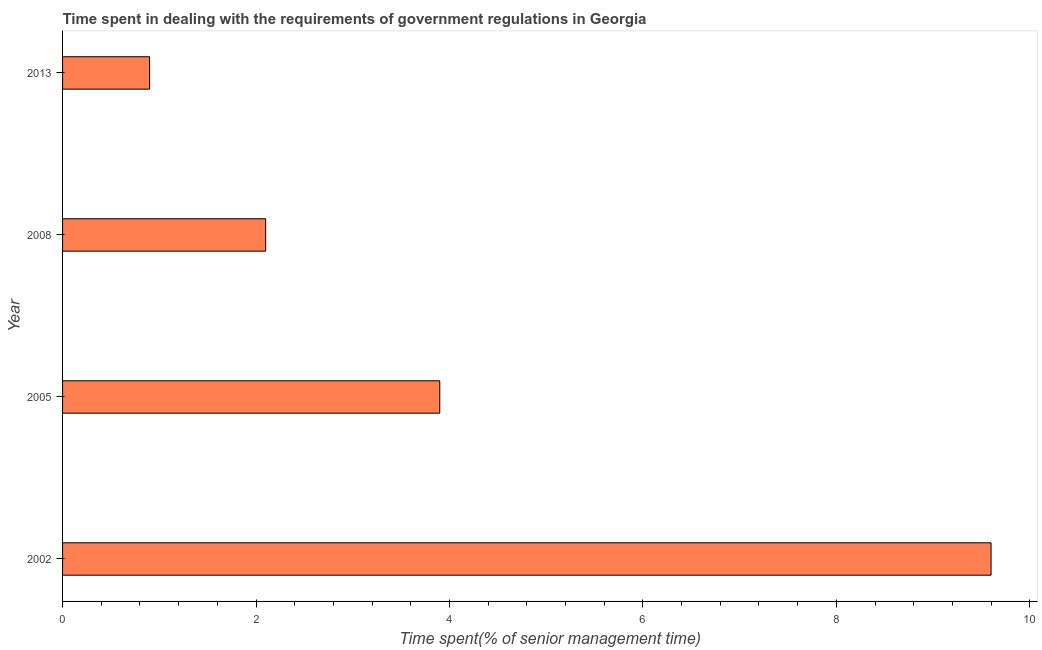Does the graph contain any zero values?
Ensure brevity in your answer.  No. What is the title of the graph?
Offer a terse response. Time spent in dealing with the requirements of government regulations in Georgia. What is the label or title of the X-axis?
Keep it short and to the point. Time spent(% of senior management time). What is the time spent in dealing with government regulations in 2005?
Your response must be concise. 3.9. Across all years, what is the maximum time spent in dealing with government regulations?
Ensure brevity in your answer.  9.6. In which year was the time spent in dealing with government regulations maximum?
Give a very brief answer. 2002. In which year was the time spent in dealing with government regulations minimum?
Your answer should be compact. 2013. What is the sum of the time spent in dealing with government regulations?
Make the answer very short. 16.5. What is the difference between the time spent in dealing with government regulations in 2002 and 2013?
Provide a succinct answer. 8.7. What is the average time spent in dealing with government regulations per year?
Ensure brevity in your answer.  4.12. What is the ratio of the time spent in dealing with government regulations in 2002 to that in 2005?
Offer a very short reply. 2.46. Is the difference between the time spent in dealing with government regulations in 2002 and 2008 greater than the difference between any two years?
Keep it short and to the point. No. What is the difference between the highest and the second highest time spent in dealing with government regulations?
Give a very brief answer. 5.7. What is the difference between the highest and the lowest time spent in dealing with government regulations?
Offer a very short reply. 8.7. How many bars are there?
Give a very brief answer. 4. Are the values on the major ticks of X-axis written in scientific E-notation?
Offer a very short reply. No. What is the Time spent(% of senior management time) of 2002?
Keep it short and to the point. 9.6. What is the Time spent(% of senior management time) in 2005?
Offer a terse response. 3.9. What is the Time spent(% of senior management time) in 2008?
Offer a very short reply. 2.1. What is the Time spent(% of senior management time) of 2013?
Give a very brief answer. 0.9. What is the difference between the Time spent(% of senior management time) in 2002 and 2008?
Keep it short and to the point. 7.5. What is the difference between the Time spent(% of senior management time) in 2005 and 2008?
Offer a very short reply. 1.8. What is the difference between the Time spent(% of senior management time) in 2005 and 2013?
Give a very brief answer. 3. What is the ratio of the Time spent(% of senior management time) in 2002 to that in 2005?
Your answer should be very brief. 2.46. What is the ratio of the Time spent(% of senior management time) in 2002 to that in 2008?
Offer a terse response. 4.57. What is the ratio of the Time spent(% of senior management time) in 2002 to that in 2013?
Ensure brevity in your answer.  10.67. What is the ratio of the Time spent(% of senior management time) in 2005 to that in 2008?
Keep it short and to the point. 1.86. What is the ratio of the Time spent(% of senior management time) in 2005 to that in 2013?
Provide a succinct answer. 4.33. What is the ratio of the Time spent(% of senior management time) in 2008 to that in 2013?
Make the answer very short. 2.33. 